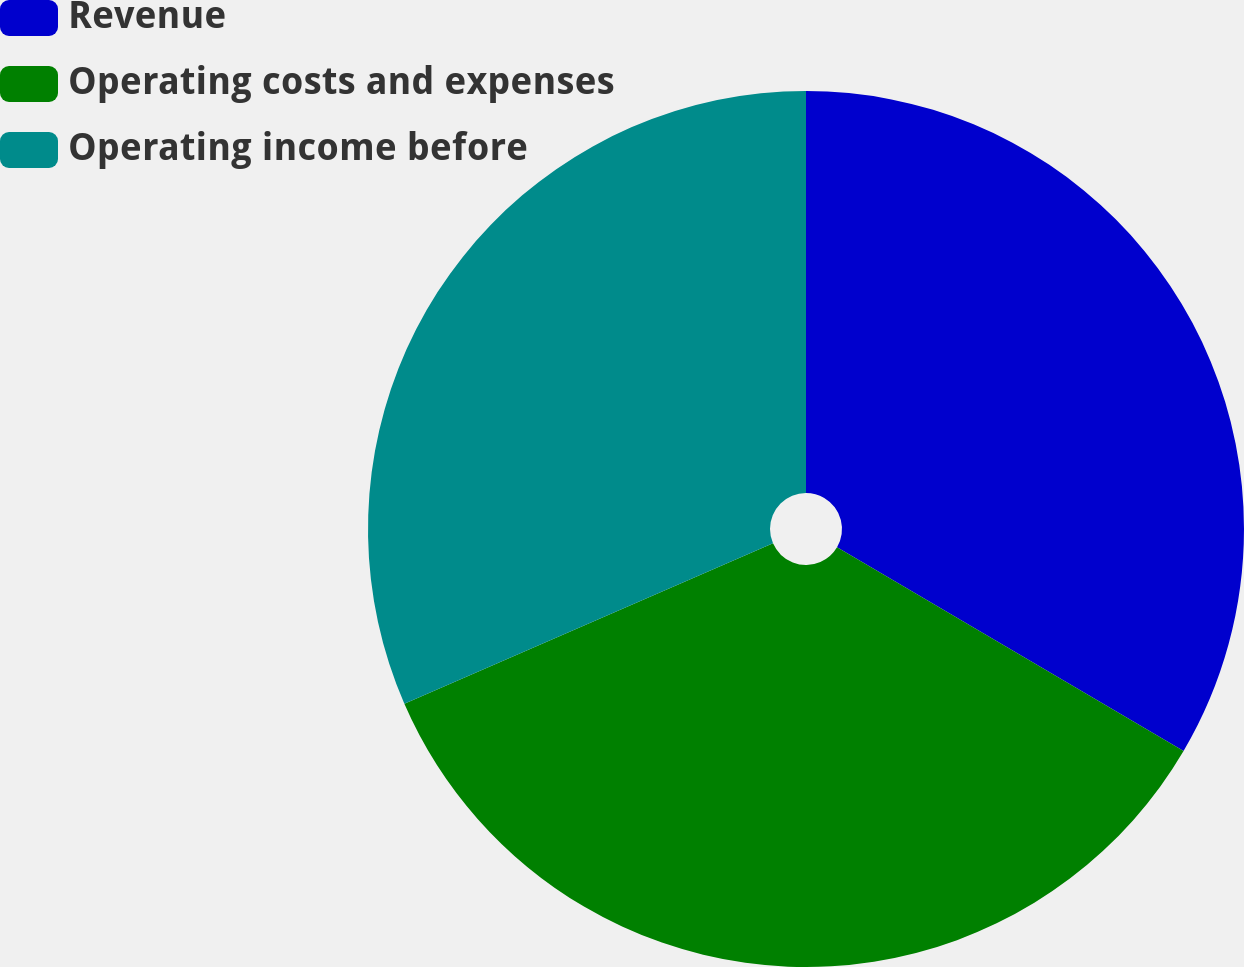Convert chart to OTSL. <chart><loc_0><loc_0><loc_500><loc_500><pie_chart><fcel>Revenue<fcel>Operating costs and expenses<fcel>Operating income before<nl><fcel>33.46%<fcel>35.01%<fcel>31.53%<nl></chart> 